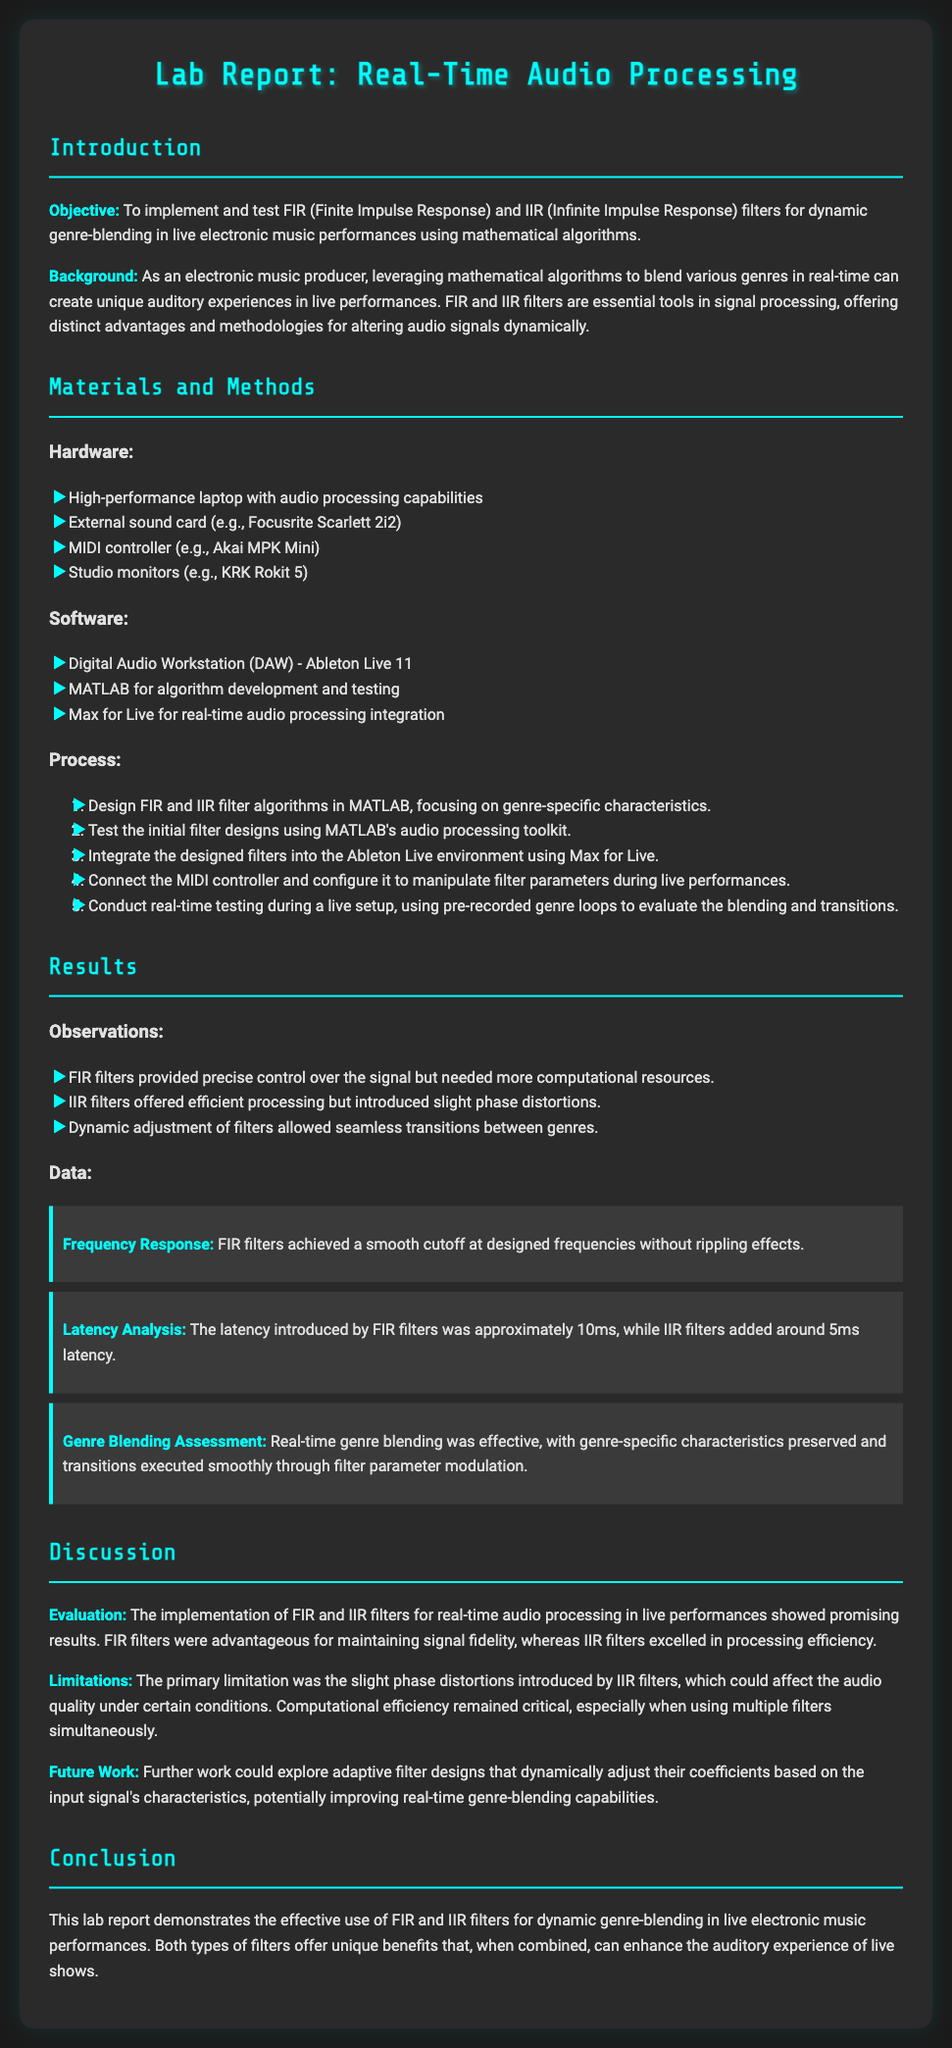What is the main objective of the lab report? The objective is stated at the beginning of the document, focusing on implementing and testing FIR and IIR filters for dynamic genre-blending in live electronic music performances.
Answer: To implement and test FIR and IIR filters for dynamic genre-blending in live performances What external sound card was used? The specific external sound card mentioned in the hardware section of the document is a Focusrite Scarlett 2i2.
Answer: Focusrite Scarlett 2i2 What software was used for algorithm development? The software used for developing and testing algorithms in the lab report is MATLAB.
Answer: MATLAB What was the approximate latency introduced by FIR filters? Latency is discussed under the results section, where it specifies that the latency introduced by FIR filters was approximately 10ms.
Answer: 10ms What is a primary limitation of IIR filters mentioned in the discussion? The limitation regarding IIR filters mentioned in the discussion is that they introduced slight phase distortions that could affect audio quality.
Answer: Slight phase distortions How did FIR filters perform in terms of signal fidelity? The report discusses FIR filters maintaining signal fidelity, which refers to their effectiveness in preserving audio quality during processing.
Answer: Maintaining signal fidelity Which digital audio workstation (DAW) was used? The specific DAW mentioned in the materials section of the report is Ableton Live 11.
Answer: Ableton Live 11 What future work could improve real-time genre-blending capabilities? The future work discussed involves exploring adaptive filter designs that dynamically adjust their coefficients based on input signal characteristics.
Answer: Adaptive filter designs What was the smoothness of the cutoff achieved by FIR filters? The results section notes that FIR filters achieved a smooth cutoff at designed frequencies without rippling effects.
Answer: A smooth cutoff 